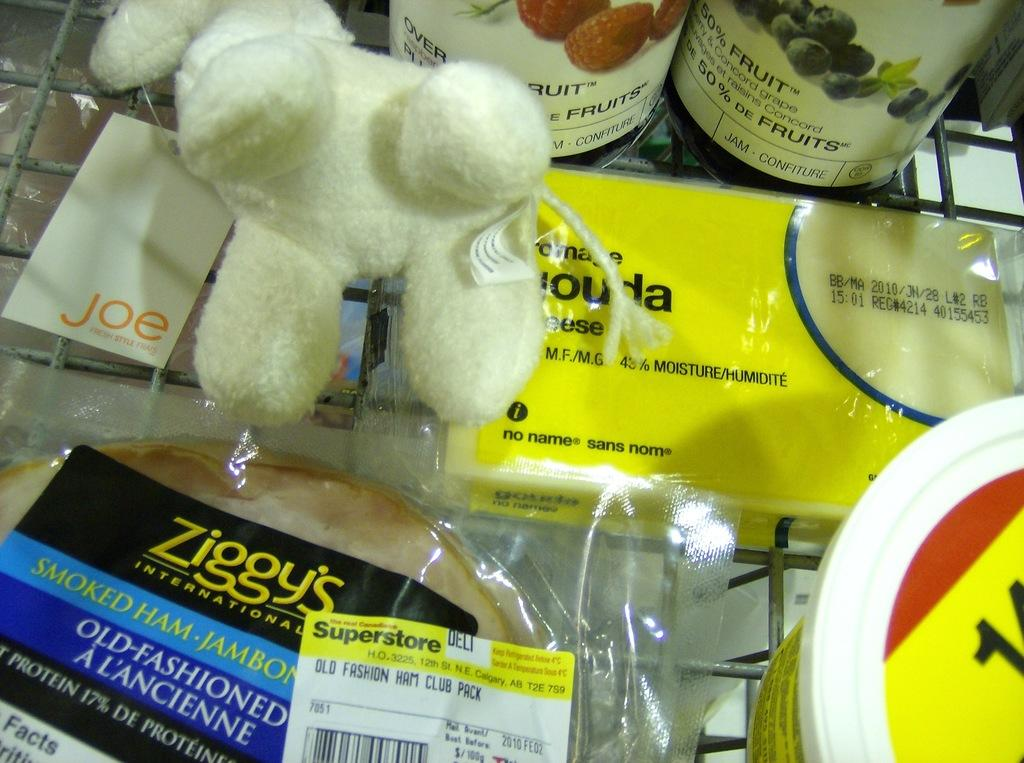What type of object can be seen in the image? There is a toy in the image. What else is present in the image besides the toy? There is packaged food, a container, and spread bottles in the image. Where are all the items located in the image? All items are on a grill. How many houses can be seen in the image? There are no houses present in the image. What type of utensil is used to eat the food on the grill? The image does not show any utensils, so it cannot be determined which type of utensil would be used to eat the food. 